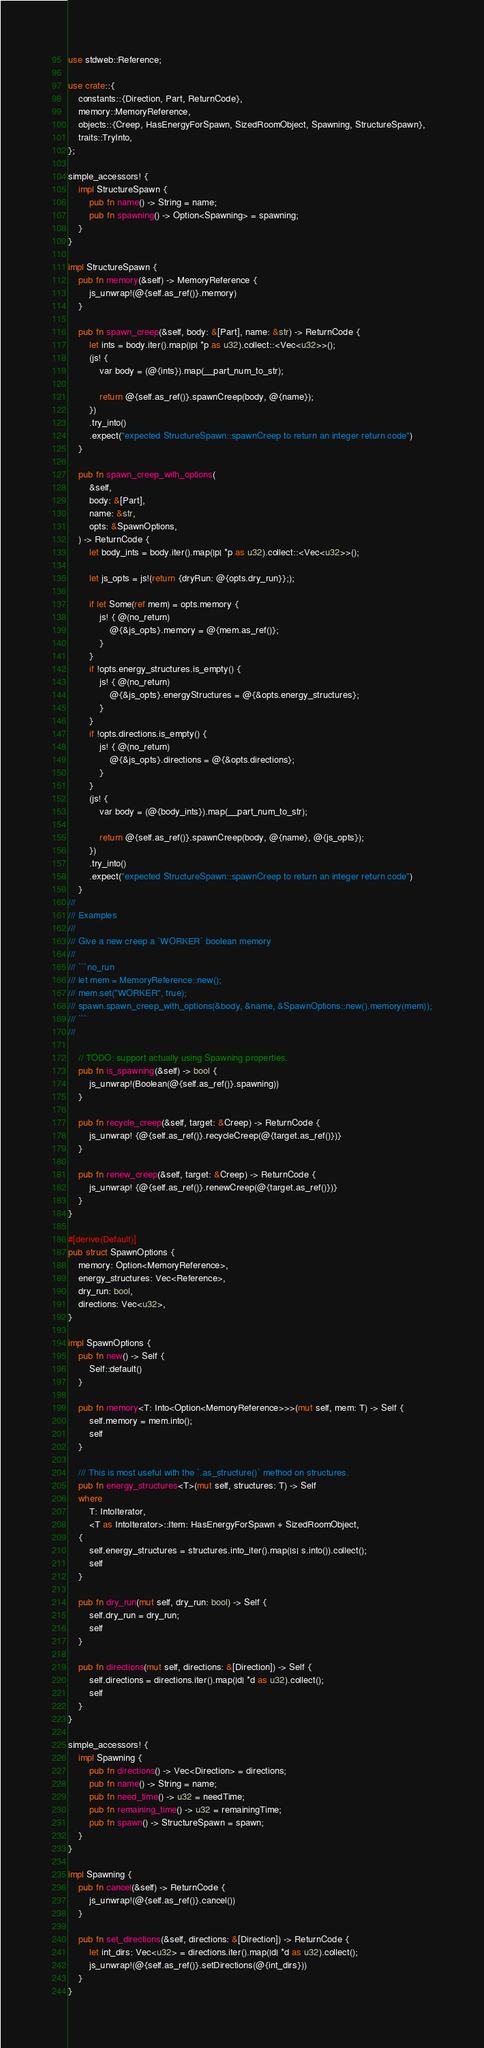Convert code to text. <code><loc_0><loc_0><loc_500><loc_500><_Rust_>use stdweb::Reference;

use crate::{
    constants::{Direction, Part, ReturnCode},
    memory::MemoryReference,
    objects::{Creep, HasEnergyForSpawn, SizedRoomObject, Spawning, StructureSpawn},
    traits::TryInto,
};

simple_accessors! {
    impl StructureSpawn {
        pub fn name() -> String = name;
        pub fn spawning() -> Option<Spawning> = spawning;
    }
}

impl StructureSpawn {
    pub fn memory(&self) -> MemoryReference {
        js_unwrap!(@{self.as_ref()}.memory)
    }

    pub fn spawn_creep(&self, body: &[Part], name: &str) -> ReturnCode {
        let ints = body.iter().map(|p| *p as u32).collect::<Vec<u32>>();
        (js! {
            var body = (@{ints}).map(__part_num_to_str);

            return @{self.as_ref()}.spawnCreep(body, @{name});
        })
        .try_into()
        .expect("expected StructureSpawn::spawnCreep to return an integer return code")
    }

    pub fn spawn_creep_with_options(
        &self,
        body: &[Part],
        name: &str,
        opts: &SpawnOptions,
    ) -> ReturnCode {
        let body_ints = body.iter().map(|p| *p as u32).collect::<Vec<u32>>();

        let js_opts = js!(return {dryRun: @{opts.dry_run}};);

        if let Some(ref mem) = opts.memory {
            js! { @(no_return)
                @{&js_opts}.memory = @{mem.as_ref()};
            }
        }
        if !opts.energy_structures.is_empty() {
            js! { @(no_return)
                @{&js_opts}.energyStructures = @{&opts.energy_structures};
            }
        }
        if !opts.directions.is_empty() {
            js! { @(no_return)
                @{&js_opts}.directions = @{&opts.directions};
            }
        }
        (js! {
            var body = (@{body_ints}).map(__part_num_to_str);

            return @{self.as_ref()}.spawnCreep(body, @{name}, @{js_opts});
        })
        .try_into()
        .expect("expected StructureSpawn::spawnCreep to return an integer return code")
    }
///
/// Examples
///
/// Give a new creep a `WORKER` boolean memory
///
/// ```no_run
/// let mem = MemoryReference::new();
/// mem.set("WORKER", true);
/// spawn.spawn_creep_with_options(&body, &name, &SpawnOptions::new().memory(mem));
/// ```
///
    
    // TODO: support actually using Spawning properties.
    pub fn is_spawning(&self) -> bool {
        js_unwrap!(Boolean(@{self.as_ref()}.spawning))
    }

    pub fn recycle_creep(&self, target: &Creep) -> ReturnCode {
        js_unwrap! {@{self.as_ref()}.recycleCreep(@{target.as_ref()})}
    }

    pub fn renew_creep(&self, target: &Creep) -> ReturnCode {
        js_unwrap! {@{self.as_ref()}.renewCreep(@{target.as_ref()})}
    }
}

#[derive(Default)]
pub struct SpawnOptions {
    memory: Option<MemoryReference>,
    energy_structures: Vec<Reference>,
    dry_run: bool,
    directions: Vec<u32>,
}

impl SpawnOptions {
    pub fn new() -> Self {
        Self::default()
    }

    pub fn memory<T: Into<Option<MemoryReference>>>(mut self, mem: T) -> Self {
        self.memory = mem.into();
        self
    }

    /// This is most useful with the `.as_structure()` method on structures.
    pub fn energy_structures<T>(mut self, structures: T) -> Self
    where
        T: IntoIterator,
        <T as IntoIterator>::Item: HasEnergyForSpawn + SizedRoomObject,
    {
        self.energy_structures = structures.into_iter().map(|s| s.into()).collect();
        self
    }

    pub fn dry_run(mut self, dry_run: bool) -> Self {
        self.dry_run = dry_run;
        self
    }

    pub fn directions(mut self, directions: &[Direction]) -> Self {
        self.directions = directions.iter().map(|d| *d as u32).collect();
        self
    }
}

simple_accessors! {
    impl Spawning {
        pub fn directions() -> Vec<Direction> = directions;
        pub fn name() -> String = name;
        pub fn need_time() -> u32 = needTime;
        pub fn remaining_time() -> u32 = remainingTime;
        pub fn spawn() -> StructureSpawn = spawn;
    }
}

impl Spawning {
    pub fn cancel(&self) -> ReturnCode {
        js_unwrap!(@{self.as_ref()}.cancel())
    }

    pub fn set_directions(&self, directions: &[Direction]) -> ReturnCode {
        let int_dirs: Vec<u32> = directions.iter().map(|d| *d as u32).collect();
        js_unwrap!(@{self.as_ref()}.setDirections(@{int_dirs}))
    }
}
</code> 